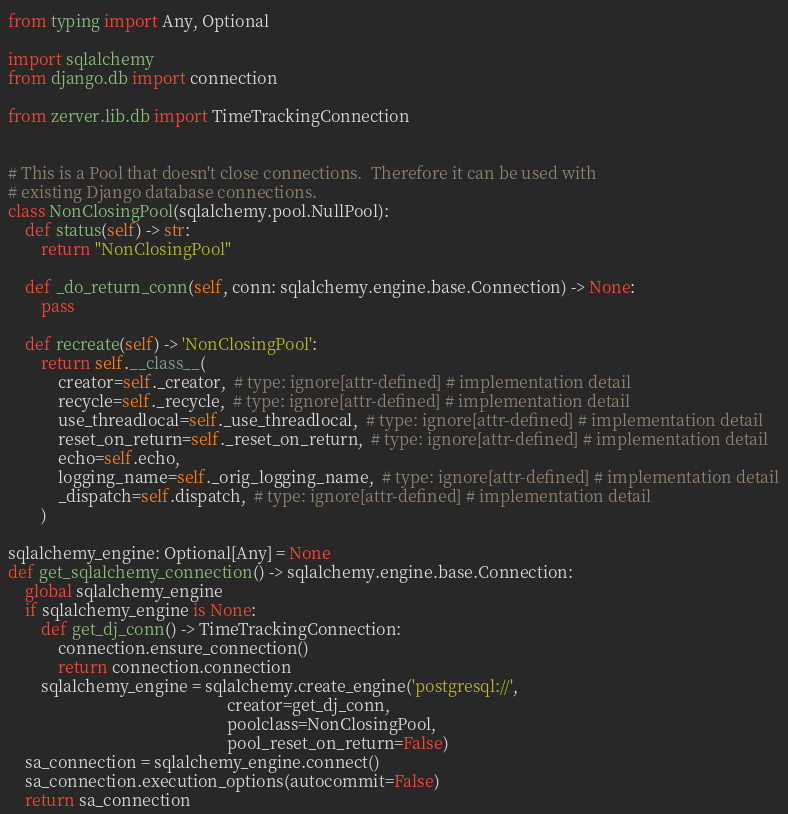Convert code to text. <code><loc_0><loc_0><loc_500><loc_500><_Python_>from typing import Any, Optional

import sqlalchemy
from django.db import connection

from zerver.lib.db import TimeTrackingConnection


# This is a Pool that doesn't close connections.  Therefore it can be used with
# existing Django database connections.
class NonClosingPool(sqlalchemy.pool.NullPool):
    def status(self) -> str:
        return "NonClosingPool"

    def _do_return_conn(self, conn: sqlalchemy.engine.base.Connection) -> None:
        pass

    def recreate(self) -> 'NonClosingPool':
        return self.__class__(
            creator=self._creator,  # type: ignore[attr-defined] # implementation detail
            recycle=self._recycle,  # type: ignore[attr-defined] # implementation detail
            use_threadlocal=self._use_threadlocal,  # type: ignore[attr-defined] # implementation detail
            reset_on_return=self._reset_on_return,  # type: ignore[attr-defined] # implementation detail
            echo=self.echo,
            logging_name=self._orig_logging_name,  # type: ignore[attr-defined] # implementation detail
            _dispatch=self.dispatch,  # type: ignore[attr-defined] # implementation detail
        )

sqlalchemy_engine: Optional[Any] = None
def get_sqlalchemy_connection() -> sqlalchemy.engine.base.Connection:
    global sqlalchemy_engine
    if sqlalchemy_engine is None:
        def get_dj_conn() -> TimeTrackingConnection:
            connection.ensure_connection()
            return connection.connection
        sqlalchemy_engine = sqlalchemy.create_engine('postgresql://',
                                                     creator=get_dj_conn,
                                                     poolclass=NonClosingPool,
                                                     pool_reset_on_return=False)
    sa_connection = sqlalchemy_engine.connect()
    sa_connection.execution_options(autocommit=False)
    return sa_connection
</code> 